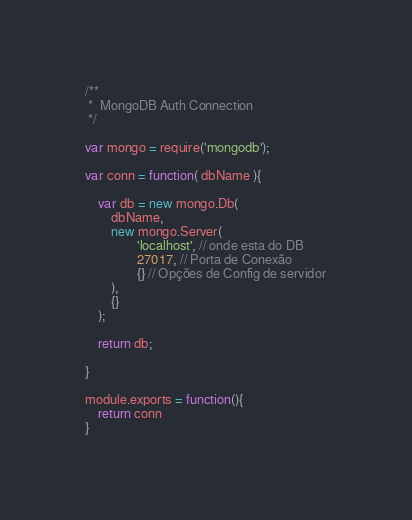<code> <loc_0><loc_0><loc_500><loc_500><_JavaScript_>/**
 *  MongoDB Auth Connection
 */

var mongo = require('mongodb');

var conn = function( dbName ){

	var db = new mongo.Db(
		dbName,
		new mongo.Server(
				'localhost', // onde esta do DB
				27017, // Porta de Conexão
				{} // Opções de Config de servidor
		),
		{}
	);

	return db;

}

module.exports = function(){
	return conn
}
</code> 